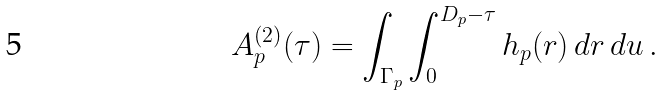Convert formula to latex. <formula><loc_0><loc_0><loc_500><loc_500>A _ { p } ^ { ( 2 ) } ( \tau ) = \int _ { \Gamma _ { p } } \int _ { 0 } ^ { D _ { p } - \tau } h _ { p } ( r ) \, d r \, d u \, .</formula> 